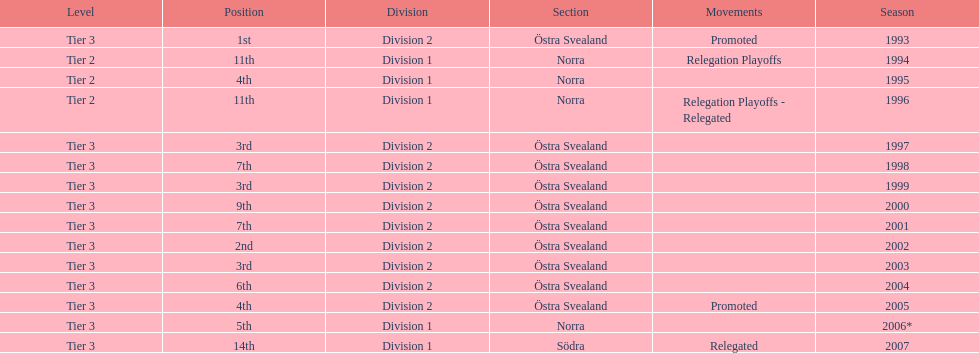They placed third in 2003. when did they place third before that? 1999. 